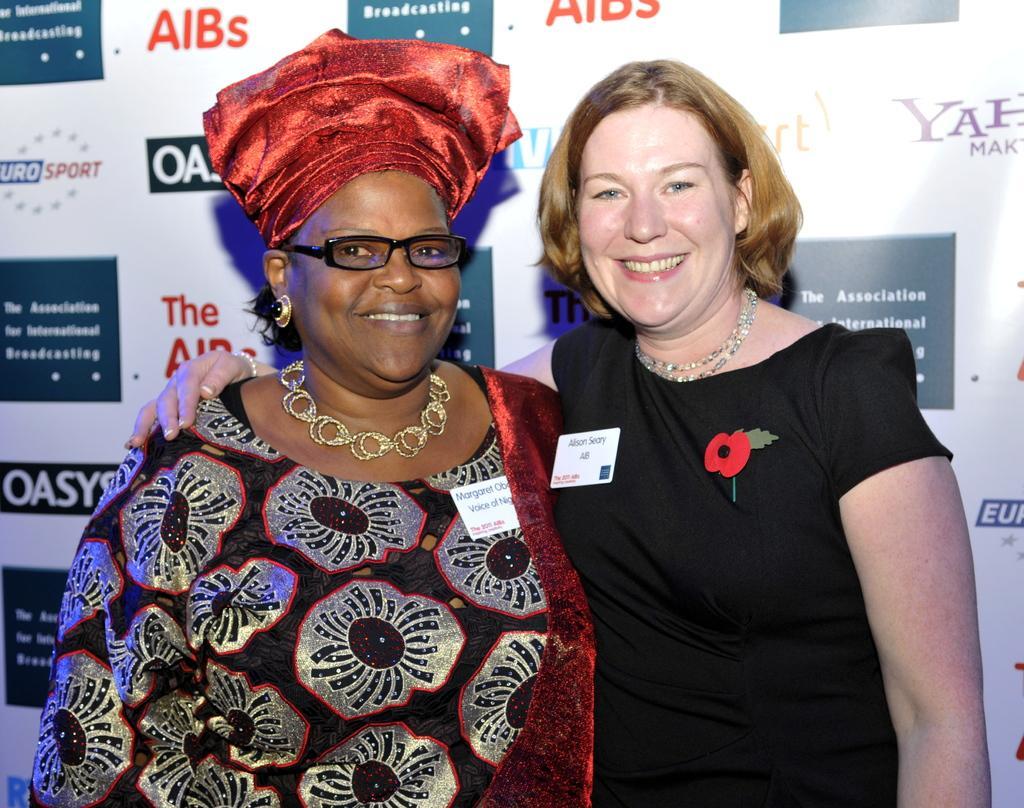How would you summarize this image in a sentence or two? In this image there are two women in the middle. The woman on the right side is standing by keeping her hand on the another woman. In the background there is a banner. There are badges to their dresses. The woman on the left side is having a cloth on her head. 